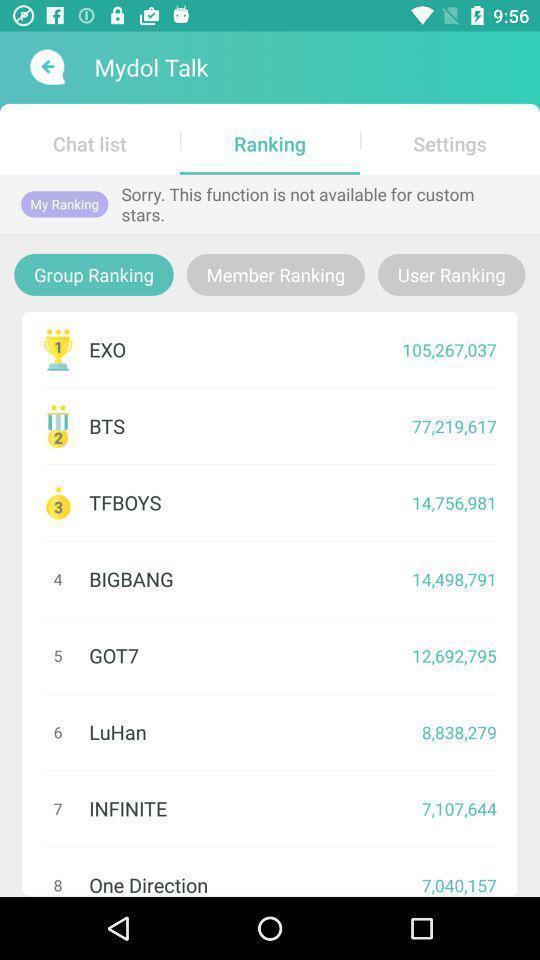Tell me about the visual elements in this screen capture. Teams ranking list showing in this page. 